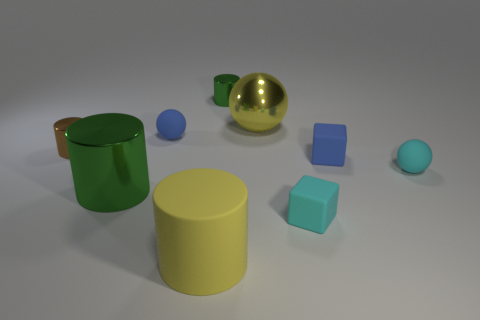What is the size of the shiny thing that is on the right side of the tiny cylinder that is on the right side of the big object that is in front of the cyan matte cube?
Ensure brevity in your answer.  Large. How big is the cylinder that is right of the big green thing and left of the tiny green cylinder?
Your response must be concise. Large. There is a metal ball on the right side of the big rubber cylinder; does it have the same color as the large cylinder right of the big green metal cylinder?
Keep it short and to the point. Yes. There is a big yellow rubber thing; what number of tiny cyan things are in front of it?
Provide a succinct answer. 0. Is there a small metallic cylinder that is on the left side of the big metal thing left of the tiny cylinder that is to the right of the small blue rubber ball?
Provide a short and direct response. Yes. How many green things have the same size as the brown cylinder?
Provide a succinct answer. 1. What is the material of the tiny sphere left of the cyan cube right of the yellow cylinder?
Offer a terse response. Rubber. There is a yellow object that is on the left side of the yellow object behind the small ball behind the tiny brown shiny thing; what is its shape?
Your answer should be compact. Cylinder. There is a green metallic object to the left of the tiny blue ball; is its shape the same as the small metal thing to the right of the big metallic cylinder?
Make the answer very short. Yes. What number of other things are the same material as the cyan block?
Your answer should be compact. 4. 